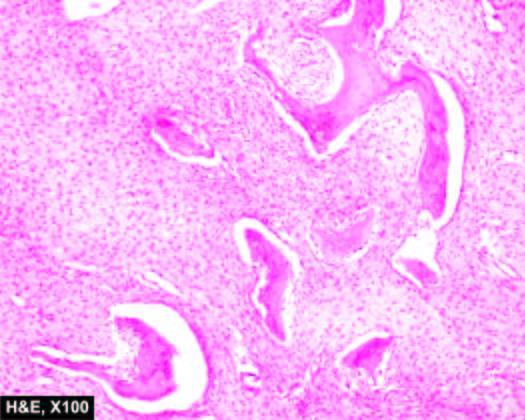what are characteristically absent?
Answer the question using a single word or phrase. Osteoblastic rimming of the bony trabeculae 